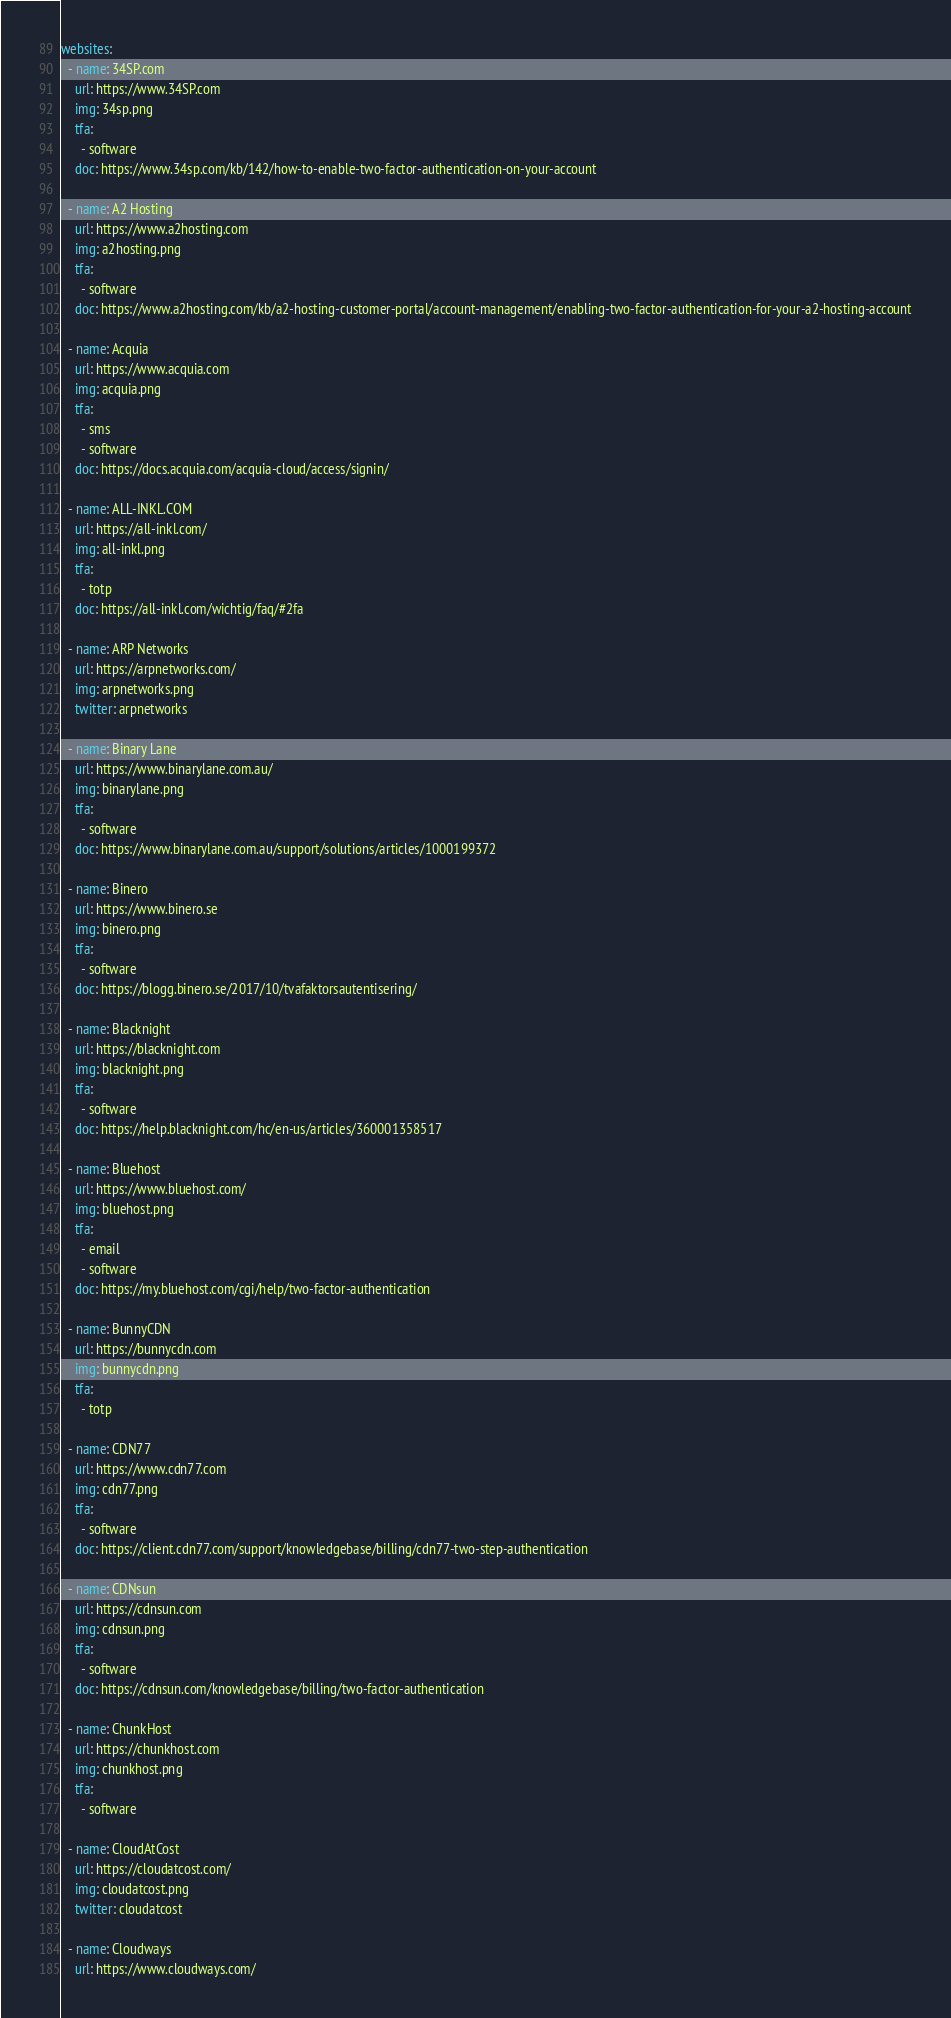Convert code to text. <code><loc_0><loc_0><loc_500><loc_500><_YAML_>websites:
  - name: 34SP.com
    url: https://www.34SP.com
    img: 34sp.png
    tfa:
      - software
    doc: https://www.34sp.com/kb/142/how-to-enable-two-factor-authentication-on-your-account

  - name: A2 Hosting
    url: https://www.a2hosting.com
    img: a2hosting.png
    tfa:
      - software
    doc: https://www.a2hosting.com/kb/a2-hosting-customer-portal/account-management/enabling-two-factor-authentication-for-your-a2-hosting-account

  - name: Acquia
    url: https://www.acquia.com
    img: acquia.png
    tfa:
      - sms
      - software
    doc: https://docs.acquia.com/acquia-cloud/access/signin/

  - name: ALL-INKL.COM
    url: https://all-inkl.com/
    img: all-inkl.png
    tfa:
      - totp
    doc: https://all-inkl.com/wichtig/faq/#2fa

  - name: ARP Networks
    url: https://arpnetworks.com/
    img: arpnetworks.png
    twitter: arpnetworks

  - name: Binary Lane
    url: https://www.binarylane.com.au/
    img: binarylane.png
    tfa:
      - software
    doc: https://www.binarylane.com.au/support/solutions/articles/1000199372

  - name: Binero
    url: https://www.binero.se
    img: binero.png
    tfa:
      - software
    doc: https://blogg.binero.se/2017/10/tvafaktorsautentisering/

  - name: Blacknight
    url: https://blacknight.com
    img: blacknight.png
    tfa:
      - software
    doc: https://help.blacknight.com/hc/en-us/articles/360001358517

  - name: Bluehost
    url: https://www.bluehost.com/
    img: bluehost.png
    tfa:
      - email
      - software
    doc: https://my.bluehost.com/cgi/help/two-factor-authentication

  - name: BunnyCDN
    url: https://bunnycdn.com
    img: bunnycdn.png
    tfa:
      - totp

  - name: CDN77
    url: https://www.cdn77.com
    img: cdn77.png
    tfa:
      - software
    doc: https://client.cdn77.com/support/knowledgebase/billing/cdn77-two-step-authentication

  - name: CDNsun
    url: https://cdnsun.com
    img: cdnsun.png
    tfa:
      - software
    doc: https://cdnsun.com/knowledgebase/billing/two-factor-authentication

  - name: ChunkHost
    url: https://chunkhost.com
    img: chunkhost.png
    tfa:
      - software

  - name: CloudAtCost
    url: https://cloudatcost.com/
    img: cloudatcost.png
    twitter: cloudatcost

  - name: Cloudways
    url: https://www.cloudways.com/</code> 